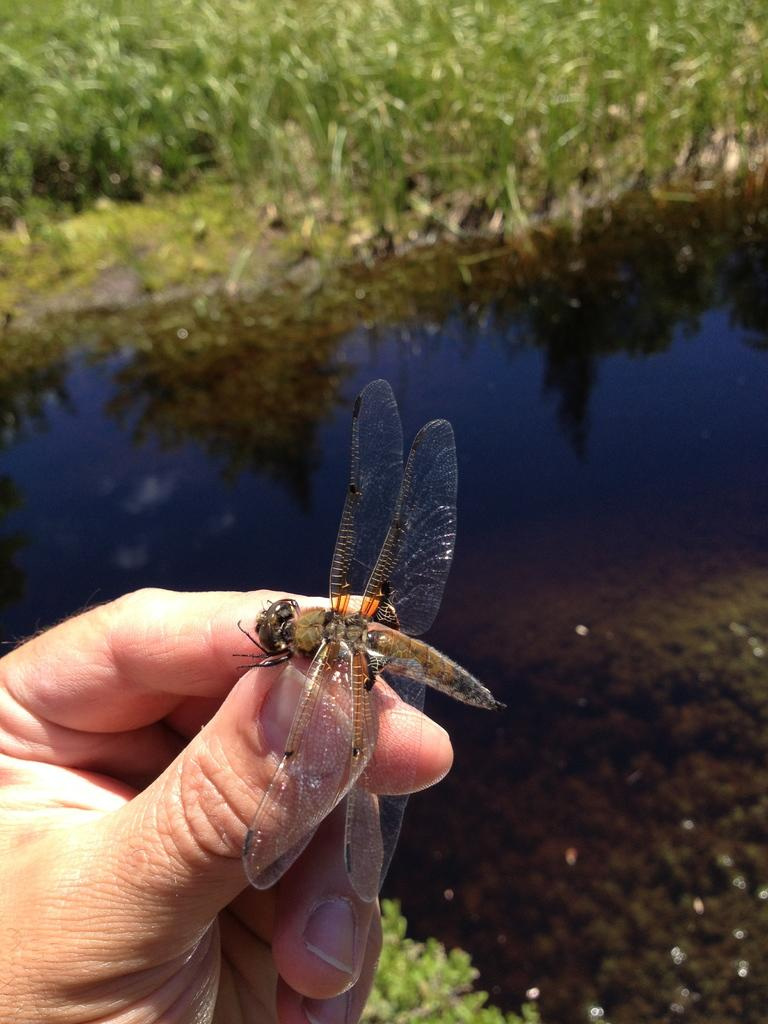What is the person's hand holding in the image? The person's hand is holding an insect in the image. Where is the insect located in the image? The insect is in a pond with water in the image. What else can be seen in the pond besides the insect? There are small plants in the pond. What type of vegetation is present on the ground in the image? There is grass on the ground in the image. What type of leather material can be seen in the image? There is no leather material present in the image. What type of beetle is visible in the image? The insect in the image is not specified as a beetle; it is simply described as an insect. 